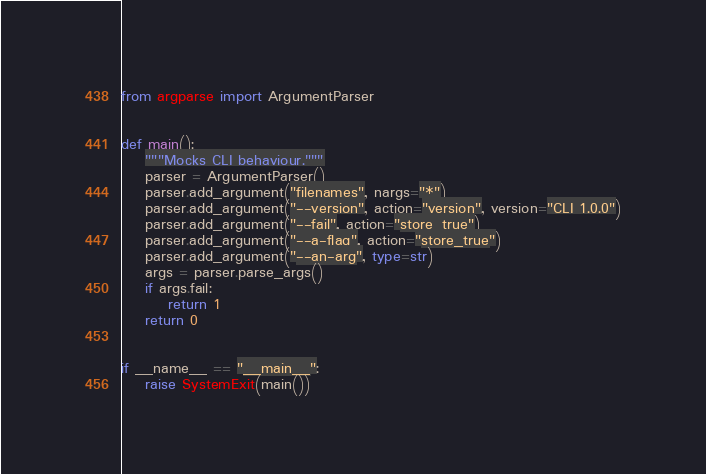Convert code to text. <code><loc_0><loc_0><loc_500><loc_500><_Python_>from argparse import ArgumentParser


def main():
    """Mocks CLI behaviour."""
    parser = ArgumentParser()
    parser.add_argument("filenames", nargs="*")
    parser.add_argument("--version", action="version", version="CLI 1.0.0")
    parser.add_argument("--fail", action="store_true")
    parser.add_argument("--a-flag", action="store_true")
    parser.add_argument("--an-arg", type=str)
    args = parser.parse_args()
    if args.fail:
        return 1
    return 0


if __name__ == "__main__":
    raise SystemExit(main())
</code> 